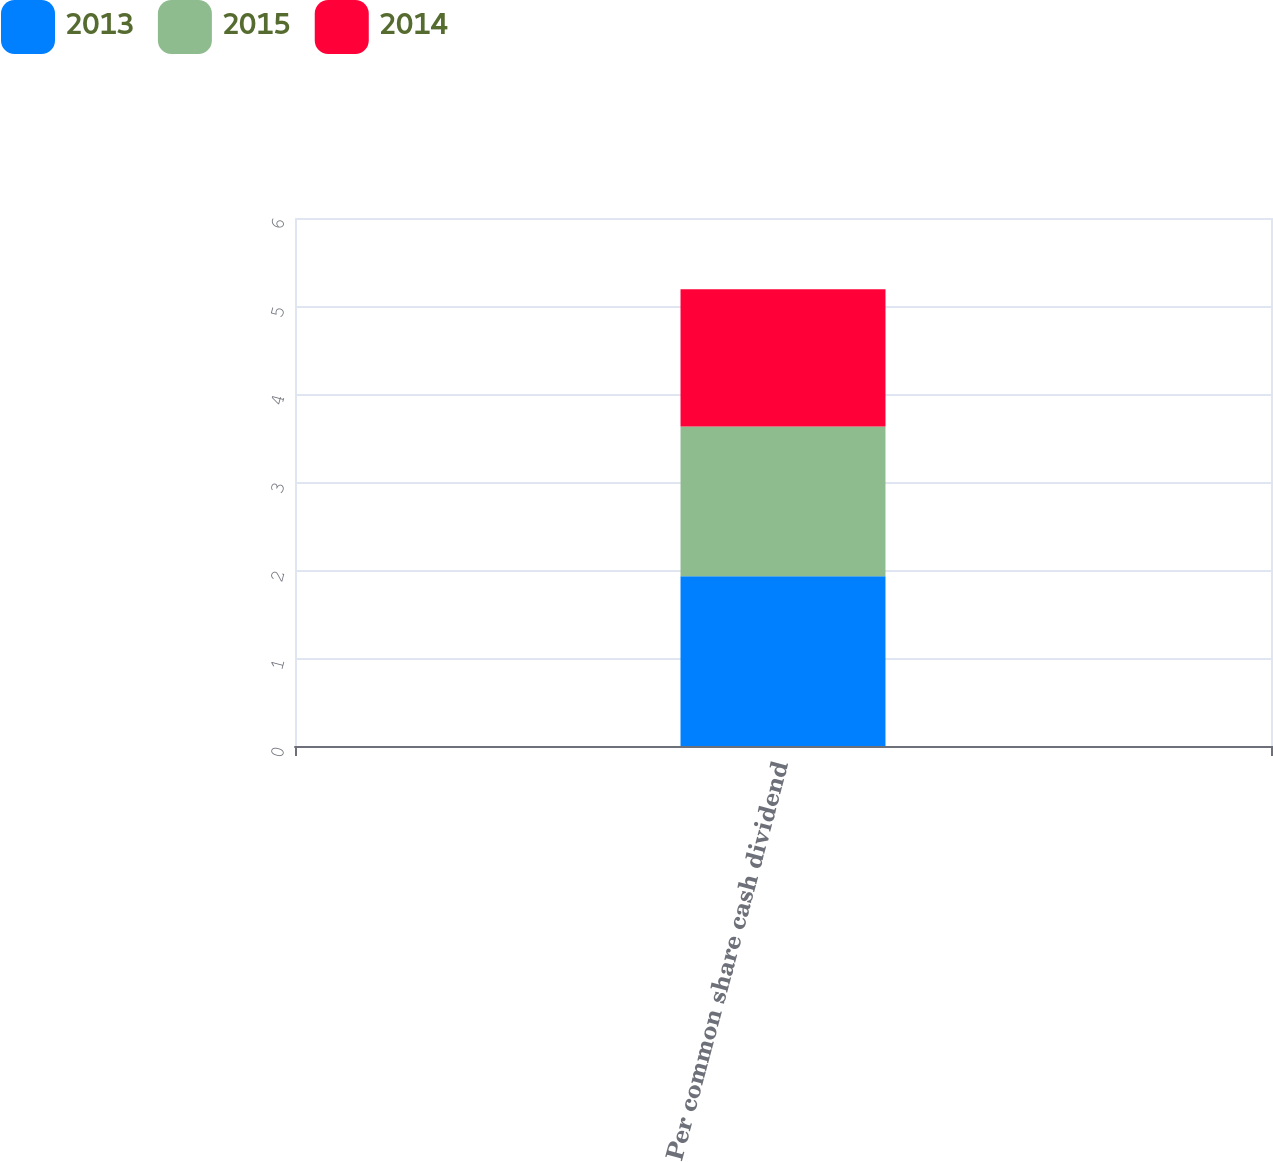<chart> <loc_0><loc_0><loc_500><loc_500><stacked_bar_chart><ecel><fcel>Per common share cash dividend<nl><fcel>2013<fcel>1.93<nl><fcel>2015<fcel>1.7<nl><fcel>2014<fcel>1.56<nl></chart> 